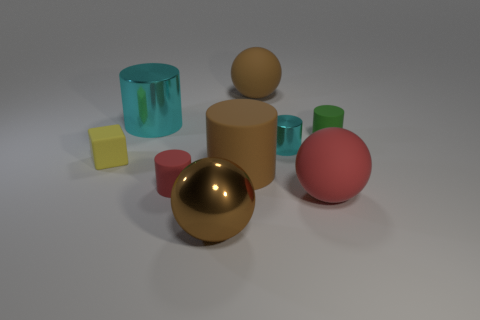Subtract all red cylinders. How many cylinders are left? 4 Add 1 red objects. How many objects exist? 10 Subtract all red cylinders. How many cylinders are left? 4 Subtract 1 green cylinders. How many objects are left? 8 Subtract all cylinders. How many objects are left? 4 Subtract 1 balls. How many balls are left? 2 Subtract all gray balls. Subtract all yellow cylinders. How many balls are left? 3 Subtract all gray cylinders. How many brown spheres are left? 2 Subtract all rubber cylinders. Subtract all tiny yellow objects. How many objects are left? 5 Add 6 large cyan objects. How many large cyan objects are left? 7 